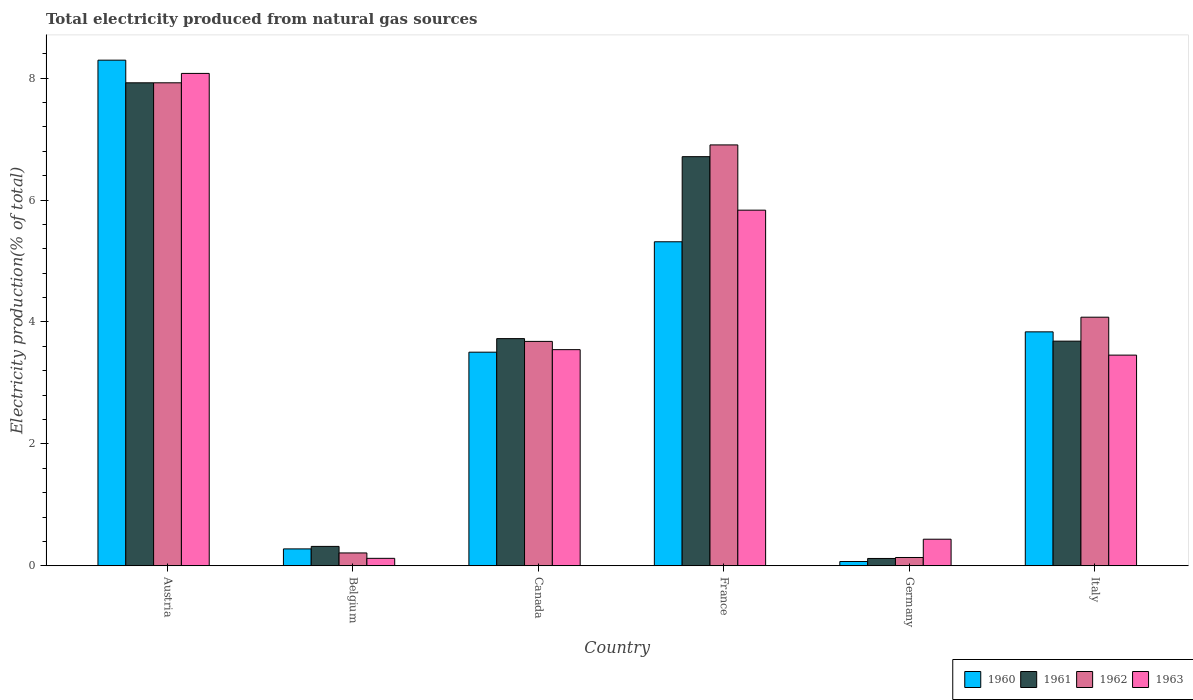How many different coloured bars are there?
Offer a very short reply. 4. How many groups of bars are there?
Make the answer very short. 6. Are the number of bars on each tick of the X-axis equal?
Offer a very short reply. Yes. How many bars are there on the 3rd tick from the left?
Give a very brief answer. 4. How many bars are there on the 2nd tick from the right?
Offer a very short reply. 4. In how many cases, is the number of bars for a given country not equal to the number of legend labels?
Your answer should be very brief. 0. What is the total electricity produced in 1961 in Italy?
Offer a terse response. 3.69. Across all countries, what is the maximum total electricity produced in 1962?
Your answer should be compact. 7.92. Across all countries, what is the minimum total electricity produced in 1961?
Ensure brevity in your answer.  0.12. In which country was the total electricity produced in 1963 minimum?
Offer a very short reply. Belgium. What is the total total electricity produced in 1962 in the graph?
Make the answer very short. 22.94. What is the difference between the total electricity produced in 1961 in Canada and that in Italy?
Keep it short and to the point. 0.04. What is the difference between the total electricity produced in 1961 in Austria and the total electricity produced in 1960 in Italy?
Offer a terse response. 4.09. What is the average total electricity produced in 1962 per country?
Provide a short and direct response. 3.82. What is the difference between the total electricity produced of/in 1963 and total electricity produced of/in 1962 in Canada?
Your answer should be very brief. -0.14. What is the ratio of the total electricity produced in 1963 in Canada to that in Germany?
Offer a very short reply. 8.13. Is the difference between the total electricity produced in 1963 in France and Italy greater than the difference between the total electricity produced in 1962 in France and Italy?
Provide a short and direct response. No. What is the difference between the highest and the second highest total electricity produced in 1963?
Keep it short and to the point. 4.53. What is the difference between the highest and the lowest total electricity produced in 1961?
Make the answer very short. 7.8. In how many countries, is the total electricity produced in 1963 greater than the average total electricity produced in 1963 taken over all countries?
Offer a very short reply. 2. Is the sum of the total electricity produced in 1960 in Austria and Italy greater than the maximum total electricity produced in 1963 across all countries?
Ensure brevity in your answer.  Yes. Is it the case that in every country, the sum of the total electricity produced in 1962 and total electricity produced in 1963 is greater than the sum of total electricity produced in 1961 and total electricity produced in 1960?
Offer a terse response. No. What does the 3rd bar from the left in Austria represents?
Your response must be concise. 1962. What does the 4th bar from the right in Belgium represents?
Make the answer very short. 1960. How many bars are there?
Make the answer very short. 24. How many countries are there in the graph?
Offer a terse response. 6. What is the difference between two consecutive major ticks on the Y-axis?
Your answer should be compact. 2. Does the graph contain any zero values?
Offer a very short reply. No. Does the graph contain grids?
Keep it short and to the point. No. Where does the legend appear in the graph?
Your response must be concise. Bottom right. How are the legend labels stacked?
Ensure brevity in your answer.  Horizontal. What is the title of the graph?
Offer a terse response. Total electricity produced from natural gas sources. What is the label or title of the X-axis?
Keep it short and to the point. Country. What is the Electricity production(% of total) of 1960 in Austria?
Offer a terse response. 8.3. What is the Electricity production(% of total) of 1961 in Austria?
Offer a very short reply. 7.92. What is the Electricity production(% of total) of 1962 in Austria?
Provide a succinct answer. 7.92. What is the Electricity production(% of total) of 1963 in Austria?
Provide a short and direct response. 8.08. What is the Electricity production(% of total) of 1960 in Belgium?
Ensure brevity in your answer.  0.28. What is the Electricity production(% of total) in 1961 in Belgium?
Provide a succinct answer. 0.32. What is the Electricity production(% of total) of 1962 in Belgium?
Keep it short and to the point. 0.21. What is the Electricity production(% of total) of 1963 in Belgium?
Provide a short and direct response. 0.12. What is the Electricity production(% of total) in 1960 in Canada?
Your answer should be compact. 3.5. What is the Electricity production(% of total) in 1961 in Canada?
Your answer should be very brief. 3.73. What is the Electricity production(% of total) in 1962 in Canada?
Give a very brief answer. 3.68. What is the Electricity production(% of total) of 1963 in Canada?
Your response must be concise. 3.55. What is the Electricity production(% of total) in 1960 in France?
Ensure brevity in your answer.  5.32. What is the Electricity production(% of total) in 1961 in France?
Give a very brief answer. 6.71. What is the Electricity production(% of total) of 1962 in France?
Provide a succinct answer. 6.91. What is the Electricity production(% of total) of 1963 in France?
Offer a very short reply. 5.83. What is the Electricity production(% of total) of 1960 in Germany?
Provide a short and direct response. 0.07. What is the Electricity production(% of total) of 1961 in Germany?
Provide a short and direct response. 0.12. What is the Electricity production(% of total) of 1962 in Germany?
Offer a terse response. 0.14. What is the Electricity production(% of total) of 1963 in Germany?
Provide a succinct answer. 0.44. What is the Electricity production(% of total) in 1960 in Italy?
Keep it short and to the point. 3.84. What is the Electricity production(% of total) in 1961 in Italy?
Offer a terse response. 3.69. What is the Electricity production(% of total) of 1962 in Italy?
Ensure brevity in your answer.  4.08. What is the Electricity production(% of total) of 1963 in Italy?
Provide a short and direct response. 3.46. Across all countries, what is the maximum Electricity production(% of total) in 1960?
Make the answer very short. 8.3. Across all countries, what is the maximum Electricity production(% of total) in 1961?
Keep it short and to the point. 7.92. Across all countries, what is the maximum Electricity production(% of total) of 1962?
Your answer should be very brief. 7.92. Across all countries, what is the maximum Electricity production(% of total) in 1963?
Offer a terse response. 8.08. Across all countries, what is the minimum Electricity production(% of total) of 1960?
Your response must be concise. 0.07. Across all countries, what is the minimum Electricity production(% of total) in 1961?
Offer a terse response. 0.12. Across all countries, what is the minimum Electricity production(% of total) in 1962?
Provide a succinct answer. 0.14. Across all countries, what is the minimum Electricity production(% of total) in 1963?
Offer a very short reply. 0.12. What is the total Electricity production(% of total) in 1960 in the graph?
Ensure brevity in your answer.  21.3. What is the total Electricity production(% of total) in 1961 in the graph?
Offer a terse response. 22.49. What is the total Electricity production(% of total) in 1962 in the graph?
Keep it short and to the point. 22.94. What is the total Electricity production(% of total) of 1963 in the graph?
Your answer should be very brief. 21.47. What is the difference between the Electricity production(% of total) of 1960 in Austria and that in Belgium?
Keep it short and to the point. 8.02. What is the difference between the Electricity production(% of total) in 1961 in Austria and that in Belgium?
Ensure brevity in your answer.  7.61. What is the difference between the Electricity production(% of total) in 1962 in Austria and that in Belgium?
Keep it short and to the point. 7.71. What is the difference between the Electricity production(% of total) of 1963 in Austria and that in Belgium?
Make the answer very short. 7.96. What is the difference between the Electricity production(% of total) of 1960 in Austria and that in Canada?
Ensure brevity in your answer.  4.79. What is the difference between the Electricity production(% of total) in 1961 in Austria and that in Canada?
Provide a succinct answer. 4.2. What is the difference between the Electricity production(% of total) of 1962 in Austria and that in Canada?
Keep it short and to the point. 4.24. What is the difference between the Electricity production(% of total) of 1963 in Austria and that in Canada?
Give a very brief answer. 4.53. What is the difference between the Electricity production(% of total) in 1960 in Austria and that in France?
Make the answer very short. 2.98. What is the difference between the Electricity production(% of total) of 1961 in Austria and that in France?
Make the answer very short. 1.21. What is the difference between the Electricity production(% of total) of 1962 in Austria and that in France?
Keep it short and to the point. 1.02. What is the difference between the Electricity production(% of total) of 1963 in Austria and that in France?
Your answer should be compact. 2.24. What is the difference between the Electricity production(% of total) of 1960 in Austria and that in Germany?
Make the answer very short. 8.23. What is the difference between the Electricity production(% of total) of 1961 in Austria and that in Germany?
Your answer should be compact. 7.8. What is the difference between the Electricity production(% of total) in 1962 in Austria and that in Germany?
Provide a succinct answer. 7.79. What is the difference between the Electricity production(% of total) of 1963 in Austria and that in Germany?
Make the answer very short. 7.64. What is the difference between the Electricity production(% of total) of 1960 in Austria and that in Italy?
Your answer should be compact. 4.46. What is the difference between the Electricity production(% of total) of 1961 in Austria and that in Italy?
Your answer should be very brief. 4.24. What is the difference between the Electricity production(% of total) in 1962 in Austria and that in Italy?
Give a very brief answer. 3.85. What is the difference between the Electricity production(% of total) of 1963 in Austria and that in Italy?
Provide a succinct answer. 4.62. What is the difference between the Electricity production(% of total) of 1960 in Belgium and that in Canada?
Provide a succinct answer. -3.23. What is the difference between the Electricity production(% of total) of 1961 in Belgium and that in Canada?
Keep it short and to the point. -3.41. What is the difference between the Electricity production(% of total) in 1962 in Belgium and that in Canada?
Your answer should be compact. -3.47. What is the difference between the Electricity production(% of total) in 1963 in Belgium and that in Canada?
Provide a short and direct response. -3.42. What is the difference between the Electricity production(% of total) of 1960 in Belgium and that in France?
Your response must be concise. -5.04. What is the difference between the Electricity production(% of total) in 1961 in Belgium and that in France?
Provide a succinct answer. -6.39. What is the difference between the Electricity production(% of total) of 1962 in Belgium and that in France?
Offer a terse response. -6.69. What is the difference between the Electricity production(% of total) in 1963 in Belgium and that in France?
Provide a short and direct response. -5.71. What is the difference between the Electricity production(% of total) in 1960 in Belgium and that in Germany?
Your response must be concise. 0.21. What is the difference between the Electricity production(% of total) in 1961 in Belgium and that in Germany?
Offer a terse response. 0.2. What is the difference between the Electricity production(% of total) in 1962 in Belgium and that in Germany?
Give a very brief answer. 0.07. What is the difference between the Electricity production(% of total) in 1963 in Belgium and that in Germany?
Your answer should be very brief. -0.31. What is the difference between the Electricity production(% of total) in 1960 in Belgium and that in Italy?
Your answer should be very brief. -3.56. What is the difference between the Electricity production(% of total) in 1961 in Belgium and that in Italy?
Give a very brief answer. -3.37. What is the difference between the Electricity production(% of total) of 1962 in Belgium and that in Italy?
Your response must be concise. -3.87. What is the difference between the Electricity production(% of total) in 1963 in Belgium and that in Italy?
Keep it short and to the point. -3.33. What is the difference between the Electricity production(% of total) of 1960 in Canada and that in France?
Ensure brevity in your answer.  -1.81. What is the difference between the Electricity production(% of total) in 1961 in Canada and that in France?
Give a very brief answer. -2.99. What is the difference between the Electricity production(% of total) of 1962 in Canada and that in France?
Keep it short and to the point. -3.22. What is the difference between the Electricity production(% of total) of 1963 in Canada and that in France?
Provide a succinct answer. -2.29. What is the difference between the Electricity production(% of total) of 1960 in Canada and that in Germany?
Provide a short and direct response. 3.43. What is the difference between the Electricity production(% of total) of 1961 in Canada and that in Germany?
Provide a short and direct response. 3.61. What is the difference between the Electricity production(% of total) in 1962 in Canada and that in Germany?
Provide a short and direct response. 3.55. What is the difference between the Electricity production(% of total) of 1963 in Canada and that in Germany?
Give a very brief answer. 3.11. What is the difference between the Electricity production(% of total) of 1960 in Canada and that in Italy?
Your answer should be very brief. -0.33. What is the difference between the Electricity production(% of total) of 1961 in Canada and that in Italy?
Your answer should be very brief. 0.04. What is the difference between the Electricity production(% of total) of 1962 in Canada and that in Italy?
Keep it short and to the point. -0.4. What is the difference between the Electricity production(% of total) of 1963 in Canada and that in Italy?
Offer a very short reply. 0.09. What is the difference between the Electricity production(% of total) in 1960 in France and that in Germany?
Make the answer very short. 5.25. What is the difference between the Electricity production(% of total) in 1961 in France and that in Germany?
Provide a short and direct response. 6.59. What is the difference between the Electricity production(% of total) of 1962 in France and that in Germany?
Provide a succinct answer. 6.77. What is the difference between the Electricity production(% of total) in 1963 in France and that in Germany?
Provide a short and direct response. 5.4. What is the difference between the Electricity production(% of total) of 1960 in France and that in Italy?
Offer a terse response. 1.48. What is the difference between the Electricity production(% of total) of 1961 in France and that in Italy?
Your response must be concise. 3.03. What is the difference between the Electricity production(% of total) in 1962 in France and that in Italy?
Give a very brief answer. 2.83. What is the difference between the Electricity production(% of total) in 1963 in France and that in Italy?
Your answer should be compact. 2.38. What is the difference between the Electricity production(% of total) of 1960 in Germany and that in Italy?
Offer a terse response. -3.77. What is the difference between the Electricity production(% of total) of 1961 in Germany and that in Italy?
Your answer should be very brief. -3.57. What is the difference between the Electricity production(% of total) in 1962 in Germany and that in Italy?
Give a very brief answer. -3.94. What is the difference between the Electricity production(% of total) of 1963 in Germany and that in Italy?
Give a very brief answer. -3.02. What is the difference between the Electricity production(% of total) in 1960 in Austria and the Electricity production(% of total) in 1961 in Belgium?
Keep it short and to the point. 7.98. What is the difference between the Electricity production(% of total) in 1960 in Austria and the Electricity production(% of total) in 1962 in Belgium?
Your response must be concise. 8.08. What is the difference between the Electricity production(% of total) in 1960 in Austria and the Electricity production(% of total) in 1963 in Belgium?
Offer a very short reply. 8.17. What is the difference between the Electricity production(% of total) of 1961 in Austria and the Electricity production(% of total) of 1962 in Belgium?
Give a very brief answer. 7.71. What is the difference between the Electricity production(% of total) in 1961 in Austria and the Electricity production(% of total) in 1963 in Belgium?
Ensure brevity in your answer.  7.8. What is the difference between the Electricity production(% of total) of 1962 in Austria and the Electricity production(% of total) of 1963 in Belgium?
Your response must be concise. 7.8. What is the difference between the Electricity production(% of total) of 1960 in Austria and the Electricity production(% of total) of 1961 in Canada?
Provide a short and direct response. 4.57. What is the difference between the Electricity production(% of total) of 1960 in Austria and the Electricity production(% of total) of 1962 in Canada?
Your response must be concise. 4.61. What is the difference between the Electricity production(% of total) of 1960 in Austria and the Electricity production(% of total) of 1963 in Canada?
Offer a terse response. 4.75. What is the difference between the Electricity production(% of total) of 1961 in Austria and the Electricity production(% of total) of 1962 in Canada?
Ensure brevity in your answer.  4.24. What is the difference between the Electricity production(% of total) of 1961 in Austria and the Electricity production(% of total) of 1963 in Canada?
Keep it short and to the point. 4.38. What is the difference between the Electricity production(% of total) in 1962 in Austria and the Electricity production(% of total) in 1963 in Canada?
Offer a terse response. 4.38. What is the difference between the Electricity production(% of total) of 1960 in Austria and the Electricity production(% of total) of 1961 in France?
Your answer should be very brief. 1.58. What is the difference between the Electricity production(% of total) of 1960 in Austria and the Electricity production(% of total) of 1962 in France?
Offer a terse response. 1.39. What is the difference between the Electricity production(% of total) of 1960 in Austria and the Electricity production(% of total) of 1963 in France?
Your answer should be very brief. 2.46. What is the difference between the Electricity production(% of total) in 1961 in Austria and the Electricity production(% of total) in 1963 in France?
Make the answer very short. 2.09. What is the difference between the Electricity production(% of total) of 1962 in Austria and the Electricity production(% of total) of 1963 in France?
Ensure brevity in your answer.  2.09. What is the difference between the Electricity production(% of total) of 1960 in Austria and the Electricity production(% of total) of 1961 in Germany?
Ensure brevity in your answer.  8.18. What is the difference between the Electricity production(% of total) of 1960 in Austria and the Electricity production(% of total) of 1962 in Germany?
Provide a short and direct response. 8.16. What is the difference between the Electricity production(% of total) of 1960 in Austria and the Electricity production(% of total) of 1963 in Germany?
Offer a terse response. 7.86. What is the difference between the Electricity production(% of total) in 1961 in Austria and the Electricity production(% of total) in 1962 in Germany?
Make the answer very short. 7.79. What is the difference between the Electricity production(% of total) in 1961 in Austria and the Electricity production(% of total) in 1963 in Germany?
Offer a very short reply. 7.49. What is the difference between the Electricity production(% of total) in 1962 in Austria and the Electricity production(% of total) in 1963 in Germany?
Provide a short and direct response. 7.49. What is the difference between the Electricity production(% of total) of 1960 in Austria and the Electricity production(% of total) of 1961 in Italy?
Provide a succinct answer. 4.61. What is the difference between the Electricity production(% of total) in 1960 in Austria and the Electricity production(% of total) in 1962 in Italy?
Your response must be concise. 4.22. What is the difference between the Electricity production(% of total) of 1960 in Austria and the Electricity production(% of total) of 1963 in Italy?
Make the answer very short. 4.84. What is the difference between the Electricity production(% of total) in 1961 in Austria and the Electricity production(% of total) in 1962 in Italy?
Your response must be concise. 3.85. What is the difference between the Electricity production(% of total) of 1961 in Austria and the Electricity production(% of total) of 1963 in Italy?
Keep it short and to the point. 4.47. What is the difference between the Electricity production(% of total) in 1962 in Austria and the Electricity production(% of total) in 1963 in Italy?
Ensure brevity in your answer.  4.47. What is the difference between the Electricity production(% of total) of 1960 in Belgium and the Electricity production(% of total) of 1961 in Canada?
Provide a short and direct response. -3.45. What is the difference between the Electricity production(% of total) in 1960 in Belgium and the Electricity production(% of total) in 1962 in Canada?
Offer a very short reply. -3.4. What is the difference between the Electricity production(% of total) in 1960 in Belgium and the Electricity production(% of total) in 1963 in Canada?
Ensure brevity in your answer.  -3.27. What is the difference between the Electricity production(% of total) of 1961 in Belgium and the Electricity production(% of total) of 1962 in Canada?
Provide a short and direct response. -3.36. What is the difference between the Electricity production(% of total) in 1961 in Belgium and the Electricity production(% of total) in 1963 in Canada?
Give a very brief answer. -3.23. What is the difference between the Electricity production(% of total) of 1962 in Belgium and the Electricity production(% of total) of 1963 in Canada?
Provide a short and direct response. -3.34. What is the difference between the Electricity production(% of total) of 1960 in Belgium and the Electricity production(% of total) of 1961 in France?
Ensure brevity in your answer.  -6.43. What is the difference between the Electricity production(% of total) in 1960 in Belgium and the Electricity production(% of total) in 1962 in France?
Your answer should be compact. -6.63. What is the difference between the Electricity production(% of total) in 1960 in Belgium and the Electricity production(% of total) in 1963 in France?
Your response must be concise. -5.56. What is the difference between the Electricity production(% of total) of 1961 in Belgium and the Electricity production(% of total) of 1962 in France?
Ensure brevity in your answer.  -6.59. What is the difference between the Electricity production(% of total) in 1961 in Belgium and the Electricity production(% of total) in 1963 in France?
Your answer should be compact. -5.52. What is the difference between the Electricity production(% of total) of 1962 in Belgium and the Electricity production(% of total) of 1963 in France?
Your answer should be very brief. -5.62. What is the difference between the Electricity production(% of total) of 1960 in Belgium and the Electricity production(% of total) of 1961 in Germany?
Ensure brevity in your answer.  0.16. What is the difference between the Electricity production(% of total) in 1960 in Belgium and the Electricity production(% of total) in 1962 in Germany?
Ensure brevity in your answer.  0.14. What is the difference between the Electricity production(% of total) of 1960 in Belgium and the Electricity production(% of total) of 1963 in Germany?
Keep it short and to the point. -0.16. What is the difference between the Electricity production(% of total) of 1961 in Belgium and the Electricity production(% of total) of 1962 in Germany?
Your answer should be compact. 0.18. What is the difference between the Electricity production(% of total) of 1961 in Belgium and the Electricity production(% of total) of 1963 in Germany?
Offer a terse response. -0.12. What is the difference between the Electricity production(% of total) of 1962 in Belgium and the Electricity production(% of total) of 1963 in Germany?
Keep it short and to the point. -0.23. What is the difference between the Electricity production(% of total) in 1960 in Belgium and the Electricity production(% of total) in 1961 in Italy?
Offer a very short reply. -3.41. What is the difference between the Electricity production(% of total) of 1960 in Belgium and the Electricity production(% of total) of 1962 in Italy?
Offer a terse response. -3.8. What is the difference between the Electricity production(% of total) of 1960 in Belgium and the Electricity production(% of total) of 1963 in Italy?
Offer a very short reply. -3.18. What is the difference between the Electricity production(% of total) in 1961 in Belgium and the Electricity production(% of total) in 1962 in Italy?
Give a very brief answer. -3.76. What is the difference between the Electricity production(% of total) in 1961 in Belgium and the Electricity production(% of total) in 1963 in Italy?
Your answer should be compact. -3.14. What is the difference between the Electricity production(% of total) in 1962 in Belgium and the Electricity production(% of total) in 1963 in Italy?
Provide a succinct answer. -3.25. What is the difference between the Electricity production(% of total) in 1960 in Canada and the Electricity production(% of total) in 1961 in France?
Offer a terse response. -3.21. What is the difference between the Electricity production(% of total) of 1960 in Canada and the Electricity production(% of total) of 1962 in France?
Offer a terse response. -3.4. What is the difference between the Electricity production(% of total) in 1960 in Canada and the Electricity production(% of total) in 1963 in France?
Your answer should be very brief. -2.33. What is the difference between the Electricity production(% of total) in 1961 in Canada and the Electricity production(% of total) in 1962 in France?
Keep it short and to the point. -3.18. What is the difference between the Electricity production(% of total) of 1961 in Canada and the Electricity production(% of total) of 1963 in France?
Your response must be concise. -2.11. What is the difference between the Electricity production(% of total) in 1962 in Canada and the Electricity production(% of total) in 1963 in France?
Provide a short and direct response. -2.15. What is the difference between the Electricity production(% of total) in 1960 in Canada and the Electricity production(% of total) in 1961 in Germany?
Provide a short and direct response. 3.38. What is the difference between the Electricity production(% of total) of 1960 in Canada and the Electricity production(% of total) of 1962 in Germany?
Your answer should be very brief. 3.37. What is the difference between the Electricity production(% of total) in 1960 in Canada and the Electricity production(% of total) in 1963 in Germany?
Your answer should be compact. 3.07. What is the difference between the Electricity production(% of total) of 1961 in Canada and the Electricity production(% of total) of 1962 in Germany?
Make the answer very short. 3.59. What is the difference between the Electricity production(% of total) of 1961 in Canada and the Electricity production(% of total) of 1963 in Germany?
Keep it short and to the point. 3.29. What is the difference between the Electricity production(% of total) in 1962 in Canada and the Electricity production(% of total) in 1963 in Germany?
Provide a short and direct response. 3.25. What is the difference between the Electricity production(% of total) in 1960 in Canada and the Electricity production(% of total) in 1961 in Italy?
Ensure brevity in your answer.  -0.18. What is the difference between the Electricity production(% of total) in 1960 in Canada and the Electricity production(% of total) in 1962 in Italy?
Offer a very short reply. -0.57. What is the difference between the Electricity production(% of total) in 1960 in Canada and the Electricity production(% of total) in 1963 in Italy?
Ensure brevity in your answer.  0.05. What is the difference between the Electricity production(% of total) of 1961 in Canada and the Electricity production(% of total) of 1962 in Italy?
Your answer should be compact. -0.35. What is the difference between the Electricity production(% of total) in 1961 in Canada and the Electricity production(% of total) in 1963 in Italy?
Your answer should be compact. 0.27. What is the difference between the Electricity production(% of total) in 1962 in Canada and the Electricity production(% of total) in 1963 in Italy?
Provide a short and direct response. 0.23. What is the difference between the Electricity production(% of total) of 1960 in France and the Electricity production(% of total) of 1961 in Germany?
Your answer should be compact. 5.2. What is the difference between the Electricity production(% of total) in 1960 in France and the Electricity production(% of total) in 1962 in Germany?
Provide a succinct answer. 5.18. What is the difference between the Electricity production(% of total) in 1960 in France and the Electricity production(% of total) in 1963 in Germany?
Make the answer very short. 4.88. What is the difference between the Electricity production(% of total) of 1961 in France and the Electricity production(% of total) of 1962 in Germany?
Make the answer very short. 6.58. What is the difference between the Electricity production(% of total) in 1961 in France and the Electricity production(% of total) in 1963 in Germany?
Give a very brief answer. 6.28. What is the difference between the Electricity production(% of total) in 1962 in France and the Electricity production(% of total) in 1963 in Germany?
Your response must be concise. 6.47. What is the difference between the Electricity production(% of total) in 1960 in France and the Electricity production(% of total) in 1961 in Italy?
Make the answer very short. 1.63. What is the difference between the Electricity production(% of total) in 1960 in France and the Electricity production(% of total) in 1962 in Italy?
Make the answer very short. 1.24. What is the difference between the Electricity production(% of total) of 1960 in France and the Electricity production(% of total) of 1963 in Italy?
Provide a succinct answer. 1.86. What is the difference between the Electricity production(% of total) of 1961 in France and the Electricity production(% of total) of 1962 in Italy?
Give a very brief answer. 2.63. What is the difference between the Electricity production(% of total) of 1961 in France and the Electricity production(% of total) of 1963 in Italy?
Your response must be concise. 3.26. What is the difference between the Electricity production(% of total) of 1962 in France and the Electricity production(% of total) of 1963 in Italy?
Your answer should be compact. 3.45. What is the difference between the Electricity production(% of total) in 1960 in Germany and the Electricity production(% of total) in 1961 in Italy?
Your answer should be very brief. -3.62. What is the difference between the Electricity production(% of total) of 1960 in Germany and the Electricity production(% of total) of 1962 in Italy?
Your answer should be compact. -4.01. What is the difference between the Electricity production(% of total) in 1960 in Germany and the Electricity production(% of total) in 1963 in Italy?
Your response must be concise. -3.39. What is the difference between the Electricity production(% of total) of 1961 in Germany and the Electricity production(% of total) of 1962 in Italy?
Provide a short and direct response. -3.96. What is the difference between the Electricity production(% of total) of 1961 in Germany and the Electricity production(% of total) of 1963 in Italy?
Ensure brevity in your answer.  -3.34. What is the difference between the Electricity production(% of total) in 1962 in Germany and the Electricity production(% of total) in 1963 in Italy?
Your answer should be very brief. -3.32. What is the average Electricity production(% of total) in 1960 per country?
Your response must be concise. 3.55. What is the average Electricity production(% of total) in 1961 per country?
Provide a short and direct response. 3.75. What is the average Electricity production(% of total) in 1962 per country?
Your answer should be very brief. 3.82. What is the average Electricity production(% of total) in 1963 per country?
Provide a short and direct response. 3.58. What is the difference between the Electricity production(% of total) in 1960 and Electricity production(% of total) in 1961 in Austria?
Make the answer very short. 0.37. What is the difference between the Electricity production(% of total) in 1960 and Electricity production(% of total) in 1962 in Austria?
Your answer should be very brief. 0.37. What is the difference between the Electricity production(% of total) of 1960 and Electricity production(% of total) of 1963 in Austria?
Provide a short and direct response. 0.22. What is the difference between the Electricity production(% of total) of 1961 and Electricity production(% of total) of 1963 in Austria?
Offer a terse response. -0.15. What is the difference between the Electricity production(% of total) of 1962 and Electricity production(% of total) of 1963 in Austria?
Ensure brevity in your answer.  -0.15. What is the difference between the Electricity production(% of total) of 1960 and Electricity production(% of total) of 1961 in Belgium?
Offer a terse response. -0.04. What is the difference between the Electricity production(% of total) of 1960 and Electricity production(% of total) of 1962 in Belgium?
Your answer should be very brief. 0.07. What is the difference between the Electricity production(% of total) of 1960 and Electricity production(% of total) of 1963 in Belgium?
Provide a short and direct response. 0.15. What is the difference between the Electricity production(% of total) of 1961 and Electricity production(% of total) of 1962 in Belgium?
Provide a succinct answer. 0.11. What is the difference between the Electricity production(% of total) in 1961 and Electricity production(% of total) in 1963 in Belgium?
Offer a terse response. 0.2. What is the difference between the Electricity production(% of total) in 1962 and Electricity production(% of total) in 1963 in Belgium?
Offer a very short reply. 0.09. What is the difference between the Electricity production(% of total) in 1960 and Electricity production(% of total) in 1961 in Canada?
Ensure brevity in your answer.  -0.22. What is the difference between the Electricity production(% of total) in 1960 and Electricity production(% of total) in 1962 in Canada?
Give a very brief answer. -0.18. What is the difference between the Electricity production(% of total) in 1960 and Electricity production(% of total) in 1963 in Canada?
Make the answer very short. -0.04. What is the difference between the Electricity production(% of total) of 1961 and Electricity production(% of total) of 1962 in Canada?
Provide a succinct answer. 0.05. What is the difference between the Electricity production(% of total) in 1961 and Electricity production(% of total) in 1963 in Canada?
Your answer should be very brief. 0.18. What is the difference between the Electricity production(% of total) in 1962 and Electricity production(% of total) in 1963 in Canada?
Keep it short and to the point. 0.14. What is the difference between the Electricity production(% of total) of 1960 and Electricity production(% of total) of 1961 in France?
Provide a short and direct response. -1.4. What is the difference between the Electricity production(% of total) of 1960 and Electricity production(% of total) of 1962 in France?
Provide a short and direct response. -1.59. What is the difference between the Electricity production(% of total) of 1960 and Electricity production(% of total) of 1963 in France?
Your answer should be very brief. -0.52. What is the difference between the Electricity production(% of total) in 1961 and Electricity production(% of total) in 1962 in France?
Keep it short and to the point. -0.19. What is the difference between the Electricity production(% of total) of 1961 and Electricity production(% of total) of 1963 in France?
Your response must be concise. 0.88. What is the difference between the Electricity production(% of total) of 1962 and Electricity production(% of total) of 1963 in France?
Ensure brevity in your answer.  1.07. What is the difference between the Electricity production(% of total) of 1960 and Electricity production(% of total) of 1961 in Germany?
Ensure brevity in your answer.  -0.05. What is the difference between the Electricity production(% of total) of 1960 and Electricity production(% of total) of 1962 in Germany?
Offer a terse response. -0.07. What is the difference between the Electricity production(% of total) in 1960 and Electricity production(% of total) in 1963 in Germany?
Give a very brief answer. -0.37. What is the difference between the Electricity production(% of total) of 1961 and Electricity production(% of total) of 1962 in Germany?
Give a very brief answer. -0.02. What is the difference between the Electricity production(% of total) of 1961 and Electricity production(% of total) of 1963 in Germany?
Offer a terse response. -0.32. What is the difference between the Electricity production(% of total) in 1962 and Electricity production(% of total) in 1963 in Germany?
Ensure brevity in your answer.  -0.3. What is the difference between the Electricity production(% of total) in 1960 and Electricity production(% of total) in 1961 in Italy?
Offer a terse response. 0.15. What is the difference between the Electricity production(% of total) in 1960 and Electricity production(% of total) in 1962 in Italy?
Your answer should be very brief. -0.24. What is the difference between the Electricity production(% of total) of 1960 and Electricity production(% of total) of 1963 in Italy?
Your answer should be compact. 0.38. What is the difference between the Electricity production(% of total) in 1961 and Electricity production(% of total) in 1962 in Italy?
Offer a very short reply. -0.39. What is the difference between the Electricity production(% of total) of 1961 and Electricity production(% of total) of 1963 in Italy?
Give a very brief answer. 0.23. What is the difference between the Electricity production(% of total) in 1962 and Electricity production(% of total) in 1963 in Italy?
Your response must be concise. 0.62. What is the ratio of the Electricity production(% of total) of 1960 in Austria to that in Belgium?
Your response must be concise. 29.93. What is the ratio of the Electricity production(% of total) of 1961 in Austria to that in Belgium?
Provide a short and direct response. 24.9. What is the ratio of the Electricity production(% of total) in 1962 in Austria to that in Belgium?
Your answer should be very brief. 37.57. What is the ratio of the Electricity production(% of total) in 1963 in Austria to that in Belgium?
Your answer should be compact. 66.07. What is the ratio of the Electricity production(% of total) in 1960 in Austria to that in Canada?
Your response must be concise. 2.37. What is the ratio of the Electricity production(% of total) of 1961 in Austria to that in Canada?
Give a very brief answer. 2.13. What is the ratio of the Electricity production(% of total) in 1962 in Austria to that in Canada?
Ensure brevity in your answer.  2.15. What is the ratio of the Electricity production(% of total) in 1963 in Austria to that in Canada?
Your response must be concise. 2.28. What is the ratio of the Electricity production(% of total) in 1960 in Austria to that in France?
Ensure brevity in your answer.  1.56. What is the ratio of the Electricity production(% of total) in 1961 in Austria to that in France?
Offer a very short reply. 1.18. What is the ratio of the Electricity production(% of total) of 1962 in Austria to that in France?
Keep it short and to the point. 1.15. What is the ratio of the Electricity production(% of total) in 1963 in Austria to that in France?
Keep it short and to the point. 1.38. What is the ratio of the Electricity production(% of total) in 1960 in Austria to that in Germany?
Your response must be concise. 118.01. What is the ratio of the Electricity production(% of total) in 1961 in Austria to that in Germany?
Provide a succinct answer. 65.86. What is the ratio of the Electricity production(% of total) of 1962 in Austria to that in Germany?
Provide a succinct answer. 58.17. What is the ratio of the Electricity production(% of total) in 1963 in Austria to that in Germany?
Your answer should be very brief. 18.52. What is the ratio of the Electricity production(% of total) in 1960 in Austria to that in Italy?
Keep it short and to the point. 2.16. What is the ratio of the Electricity production(% of total) of 1961 in Austria to that in Italy?
Your answer should be compact. 2.15. What is the ratio of the Electricity production(% of total) of 1962 in Austria to that in Italy?
Make the answer very short. 1.94. What is the ratio of the Electricity production(% of total) of 1963 in Austria to that in Italy?
Your answer should be compact. 2.34. What is the ratio of the Electricity production(% of total) of 1960 in Belgium to that in Canada?
Keep it short and to the point. 0.08. What is the ratio of the Electricity production(% of total) of 1961 in Belgium to that in Canada?
Your answer should be compact. 0.09. What is the ratio of the Electricity production(% of total) of 1962 in Belgium to that in Canada?
Offer a very short reply. 0.06. What is the ratio of the Electricity production(% of total) in 1963 in Belgium to that in Canada?
Keep it short and to the point. 0.03. What is the ratio of the Electricity production(% of total) in 1960 in Belgium to that in France?
Ensure brevity in your answer.  0.05. What is the ratio of the Electricity production(% of total) in 1961 in Belgium to that in France?
Provide a short and direct response. 0.05. What is the ratio of the Electricity production(% of total) of 1962 in Belgium to that in France?
Make the answer very short. 0.03. What is the ratio of the Electricity production(% of total) in 1963 in Belgium to that in France?
Your answer should be very brief. 0.02. What is the ratio of the Electricity production(% of total) in 1960 in Belgium to that in Germany?
Your answer should be very brief. 3.94. What is the ratio of the Electricity production(% of total) in 1961 in Belgium to that in Germany?
Your answer should be compact. 2.64. What is the ratio of the Electricity production(% of total) in 1962 in Belgium to that in Germany?
Give a very brief answer. 1.55. What is the ratio of the Electricity production(% of total) of 1963 in Belgium to that in Germany?
Ensure brevity in your answer.  0.28. What is the ratio of the Electricity production(% of total) of 1960 in Belgium to that in Italy?
Your response must be concise. 0.07. What is the ratio of the Electricity production(% of total) of 1961 in Belgium to that in Italy?
Make the answer very short. 0.09. What is the ratio of the Electricity production(% of total) in 1962 in Belgium to that in Italy?
Offer a terse response. 0.05. What is the ratio of the Electricity production(% of total) in 1963 in Belgium to that in Italy?
Give a very brief answer. 0.04. What is the ratio of the Electricity production(% of total) of 1960 in Canada to that in France?
Make the answer very short. 0.66. What is the ratio of the Electricity production(% of total) in 1961 in Canada to that in France?
Make the answer very short. 0.56. What is the ratio of the Electricity production(% of total) of 1962 in Canada to that in France?
Provide a succinct answer. 0.53. What is the ratio of the Electricity production(% of total) in 1963 in Canada to that in France?
Provide a succinct answer. 0.61. What is the ratio of the Electricity production(% of total) of 1960 in Canada to that in Germany?
Provide a succinct answer. 49.85. What is the ratio of the Electricity production(% of total) in 1961 in Canada to that in Germany?
Your answer should be very brief. 30.98. What is the ratio of the Electricity production(% of total) in 1962 in Canada to that in Germany?
Your answer should be compact. 27.02. What is the ratio of the Electricity production(% of total) of 1963 in Canada to that in Germany?
Provide a succinct answer. 8.13. What is the ratio of the Electricity production(% of total) of 1960 in Canada to that in Italy?
Keep it short and to the point. 0.91. What is the ratio of the Electricity production(% of total) in 1961 in Canada to that in Italy?
Give a very brief answer. 1.01. What is the ratio of the Electricity production(% of total) of 1962 in Canada to that in Italy?
Your answer should be compact. 0.9. What is the ratio of the Electricity production(% of total) in 1963 in Canada to that in Italy?
Keep it short and to the point. 1.03. What is the ratio of the Electricity production(% of total) of 1960 in France to that in Germany?
Provide a short and direct response. 75.62. What is the ratio of the Electricity production(% of total) of 1961 in France to that in Germany?
Make the answer very short. 55.79. What is the ratio of the Electricity production(% of total) of 1962 in France to that in Germany?
Offer a very short reply. 50.69. What is the ratio of the Electricity production(% of total) of 1963 in France to that in Germany?
Provide a short and direct response. 13.38. What is the ratio of the Electricity production(% of total) in 1960 in France to that in Italy?
Your response must be concise. 1.39. What is the ratio of the Electricity production(% of total) of 1961 in France to that in Italy?
Ensure brevity in your answer.  1.82. What is the ratio of the Electricity production(% of total) in 1962 in France to that in Italy?
Make the answer very short. 1.69. What is the ratio of the Electricity production(% of total) of 1963 in France to that in Italy?
Give a very brief answer. 1.69. What is the ratio of the Electricity production(% of total) in 1960 in Germany to that in Italy?
Make the answer very short. 0.02. What is the ratio of the Electricity production(% of total) in 1961 in Germany to that in Italy?
Offer a very short reply. 0.03. What is the ratio of the Electricity production(% of total) in 1962 in Germany to that in Italy?
Your answer should be compact. 0.03. What is the ratio of the Electricity production(% of total) in 1963 in Germany to that in Italy?
Your response must be concise. 0.13. What is the difference between the highest and the second highest Electricity production(% of total) of 1960?
Offer a terse response. 2.98. What is the difference between the highest and the second highest Electricity production(% of total) in 1961?
Your answer should be compact. 1.21. What is the difference between the highest and the second highest Electricity production(% of total) in 1962?
Make the answer very short. 1.02. What is the difference between the highest and the second highest Electricity production(% of total) of 1963?
Provide a succinct answer. 2.24. What is the difference between the highest and the lowest Electricity production(% of total) of 1960?
Keep it short and to the point. 8.23. What is the difference between the highest and the lowest Electricity production(% of total) in 1961?
Your answer should be very brief. 7.8. What is the difference between the highest and the lowest Electricity production(% of total) of 1962?
Your response must be concise. 7.79. What is the difference between the highest and the lowest Electricity production(% of total) in 1963?
Give a very brief answer. 7.96. 